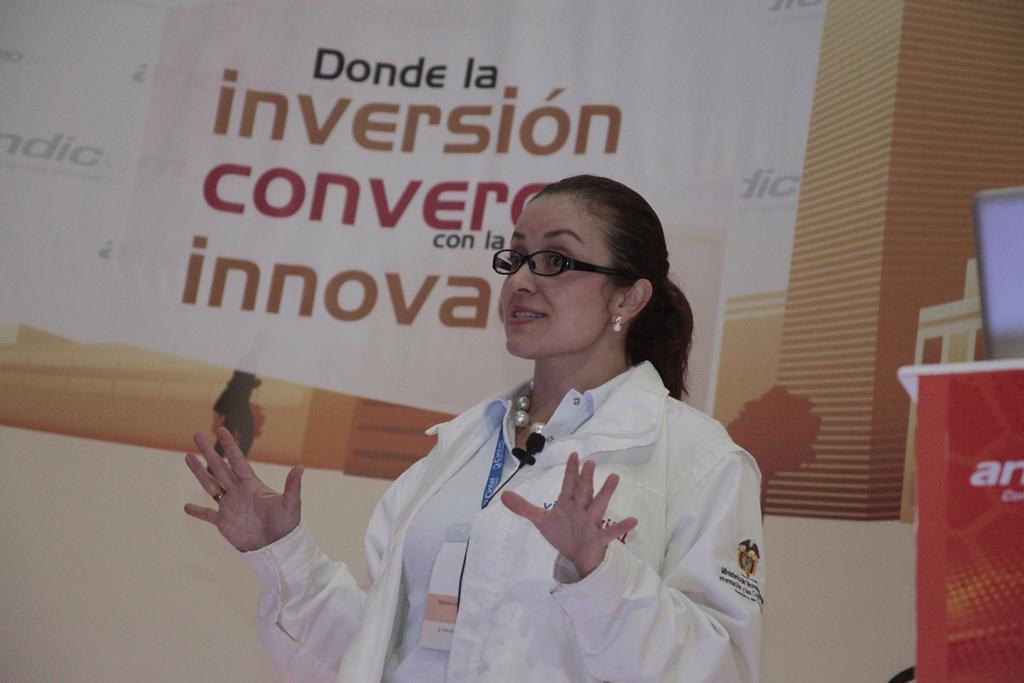Can you describe this image briefly? This is the woman standing and smiling. She wore spectacles, earrings, badge and white colored jacket. I think this is the banner which is hanging. 